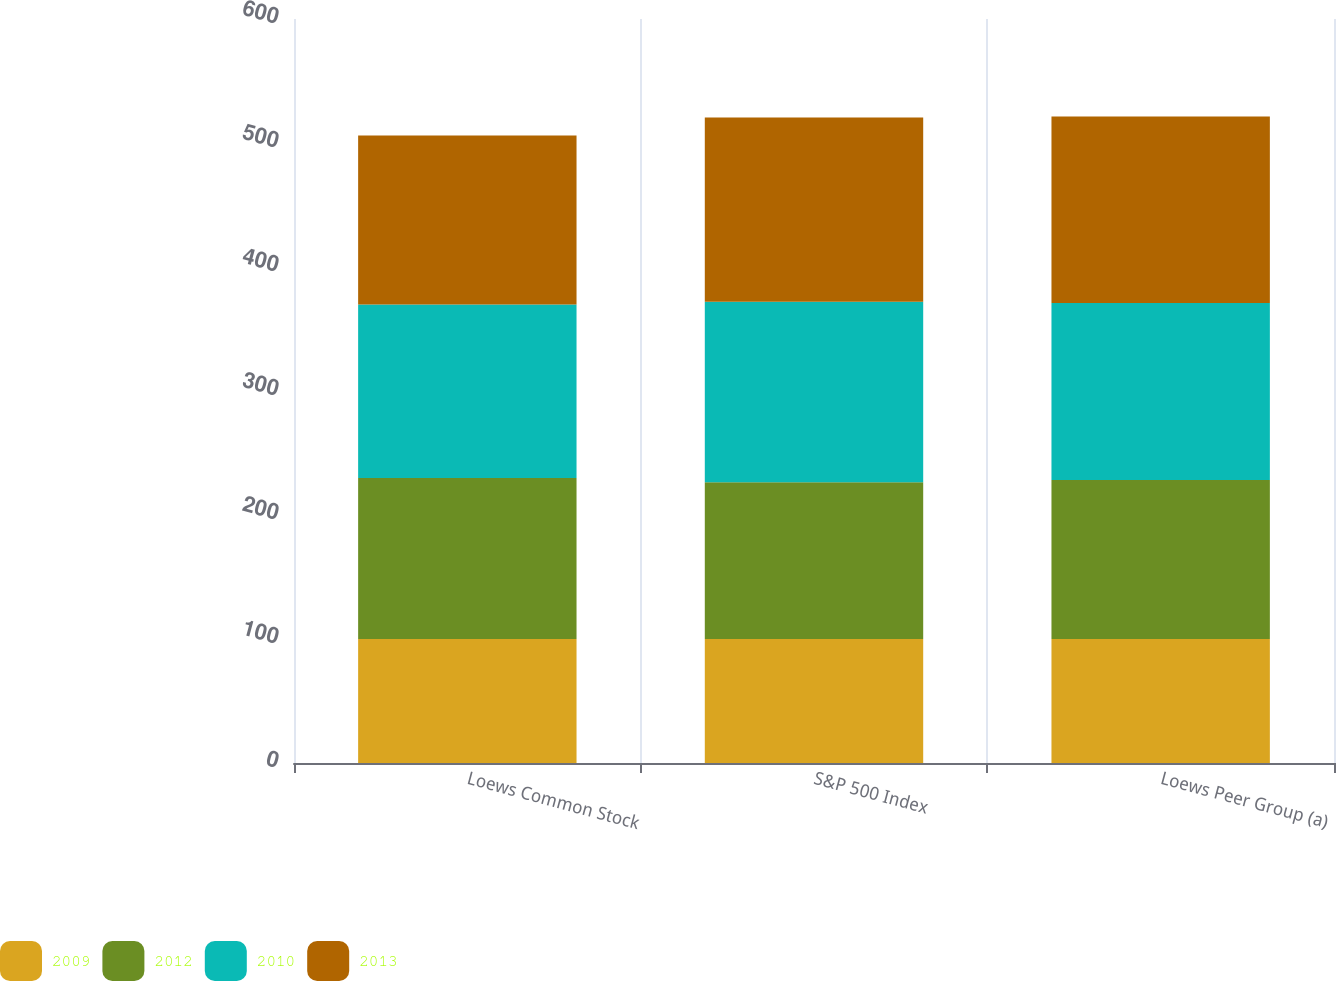Convert chart. <chart><loc_0><loc_0><loc_500><loc_500><stacked_bar_chart><ecel><fcel>Loews Common Stock<fcel>S&P 500 Index<fcel>Loews Peer Group (a)<nl><fcel>2009<fcel>100<fcel>100<fcel>100<nl><fcel>2012<fcel>129.84<fcel>126.46<fcel>128.27<nl><fcel>2010<fcel>139.97<fcel>145.51<fcel>142.73<nl><fcel>2013<fcel>136.28<fcel>148.59<fcel>150.43<nl></chart> 